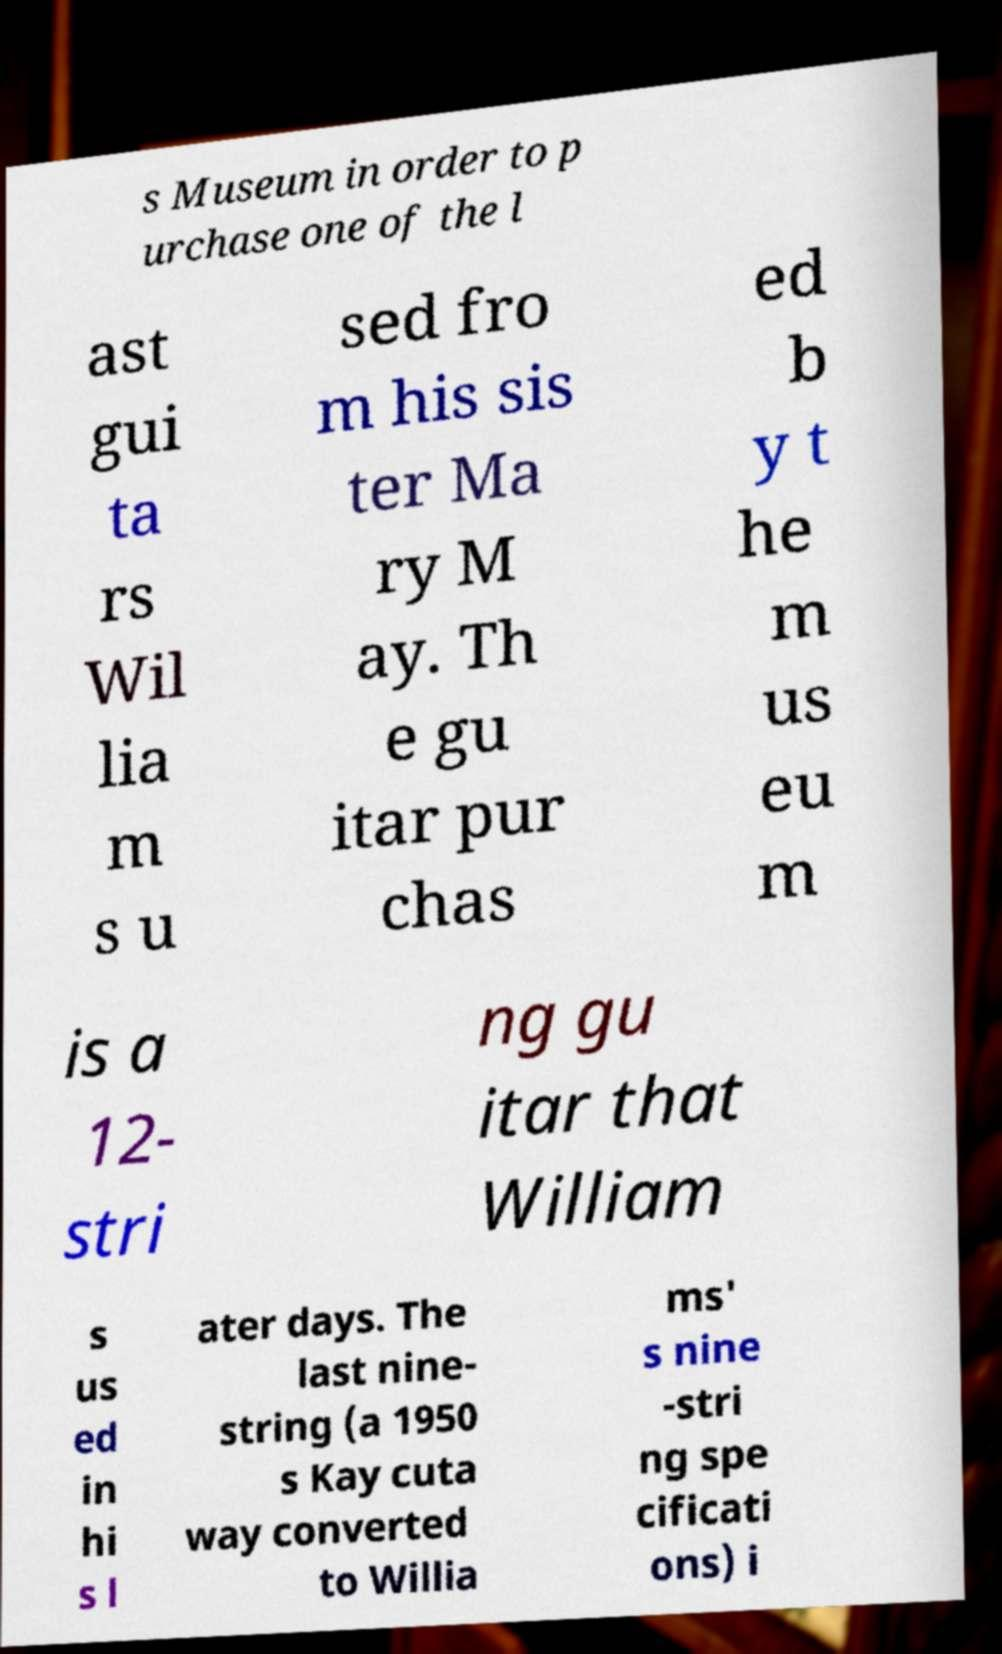Could you extract and type out the text from this image? s Museum in order to p urchase one of the l ast gui ta rs Wil lia m s u sed fro m his sis ter Ma ry M ay. Th e gu itar pur chas ed b y t he m us eu m is a 12- stri ng gu itar that William s us ed in hi s l ater days. The last nine- string (a 1950 s Kay cuta way converted to Willia ms' s nine -stri ng spe cificati ons) i 